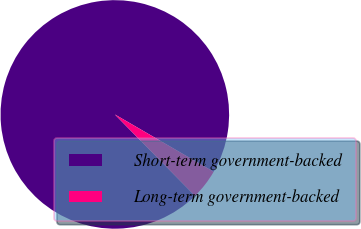<chart> <loc_0><loc_0><loc_500><loc_500><pie_chart><fcel>Short-term government-backed<fcel>Long-term government-backed<nl><fcel>95.74%<fcel>4.26%<nl></chart> 